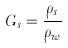<formula> <loc_0><loc_0><loc_500><loc_500>G _ { s } = \frac { \rho _ { s } } { \rho _ { w } }</formula> 